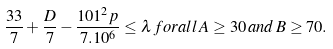Convert formula to latex. <formula><loc_0><loc_0><loc_500><loc_500>\frac { 3 3 } { 7 } + \frac { D } { 7 } - \frac { 1 0 1 ^ { 2 } p } { 7 . 1 0 ^ { 6 } } \leq \lambda \, f o r a l l \, A \geq 3 0 \, a n d \, B \geq 7 0 .</formula> 